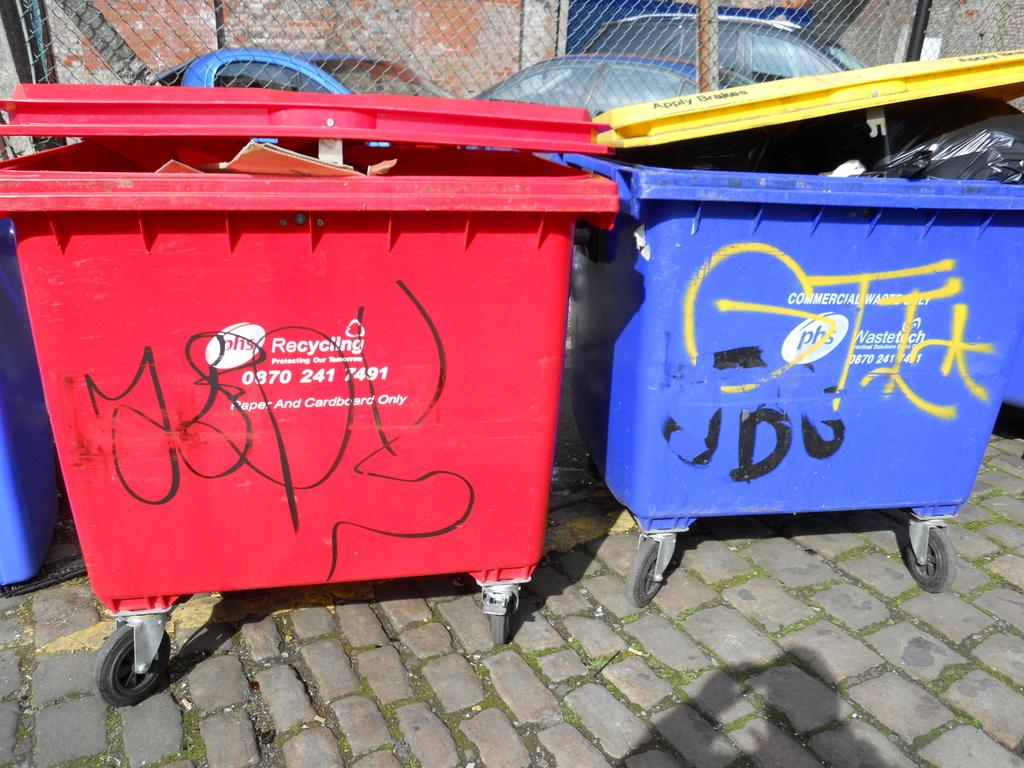<image>
Give a short and clear explanation of the subsequent image. A red bin on wheels is for recycling paper and cardboard only. 